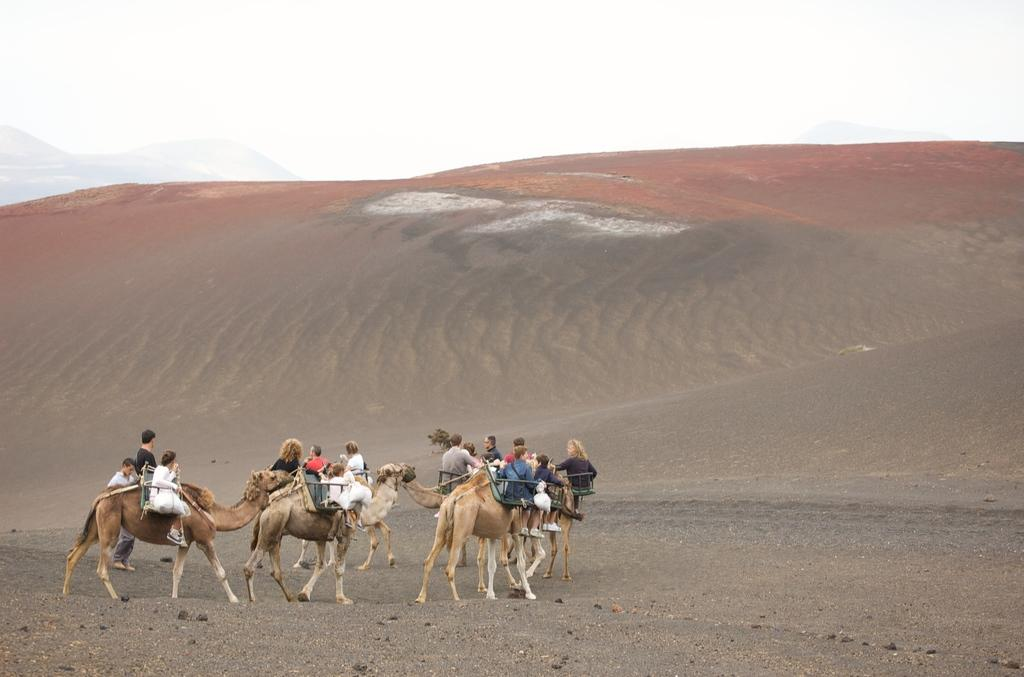What are the people in the image doing? The people in the image are sitting on camels. What type of environment is visible in the background of the image? There is a desert visible in the background of the image. What is visible at the top of the image? The sky is visible at the top of the image. What type of furniture can be seen in the bedroom in the image? There is no bedroom present in the image; it features a group of people sitting on camels in a desert environment. 